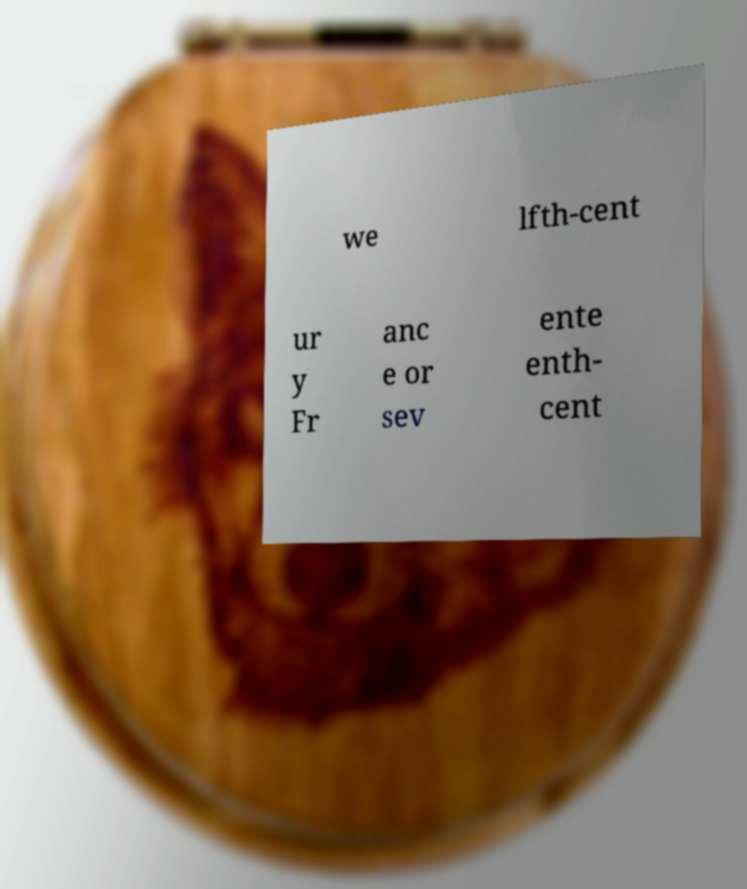Could you extract and type out the text from this image? we lfth-cent ur y Fr anc e or sev ente enth- cent 